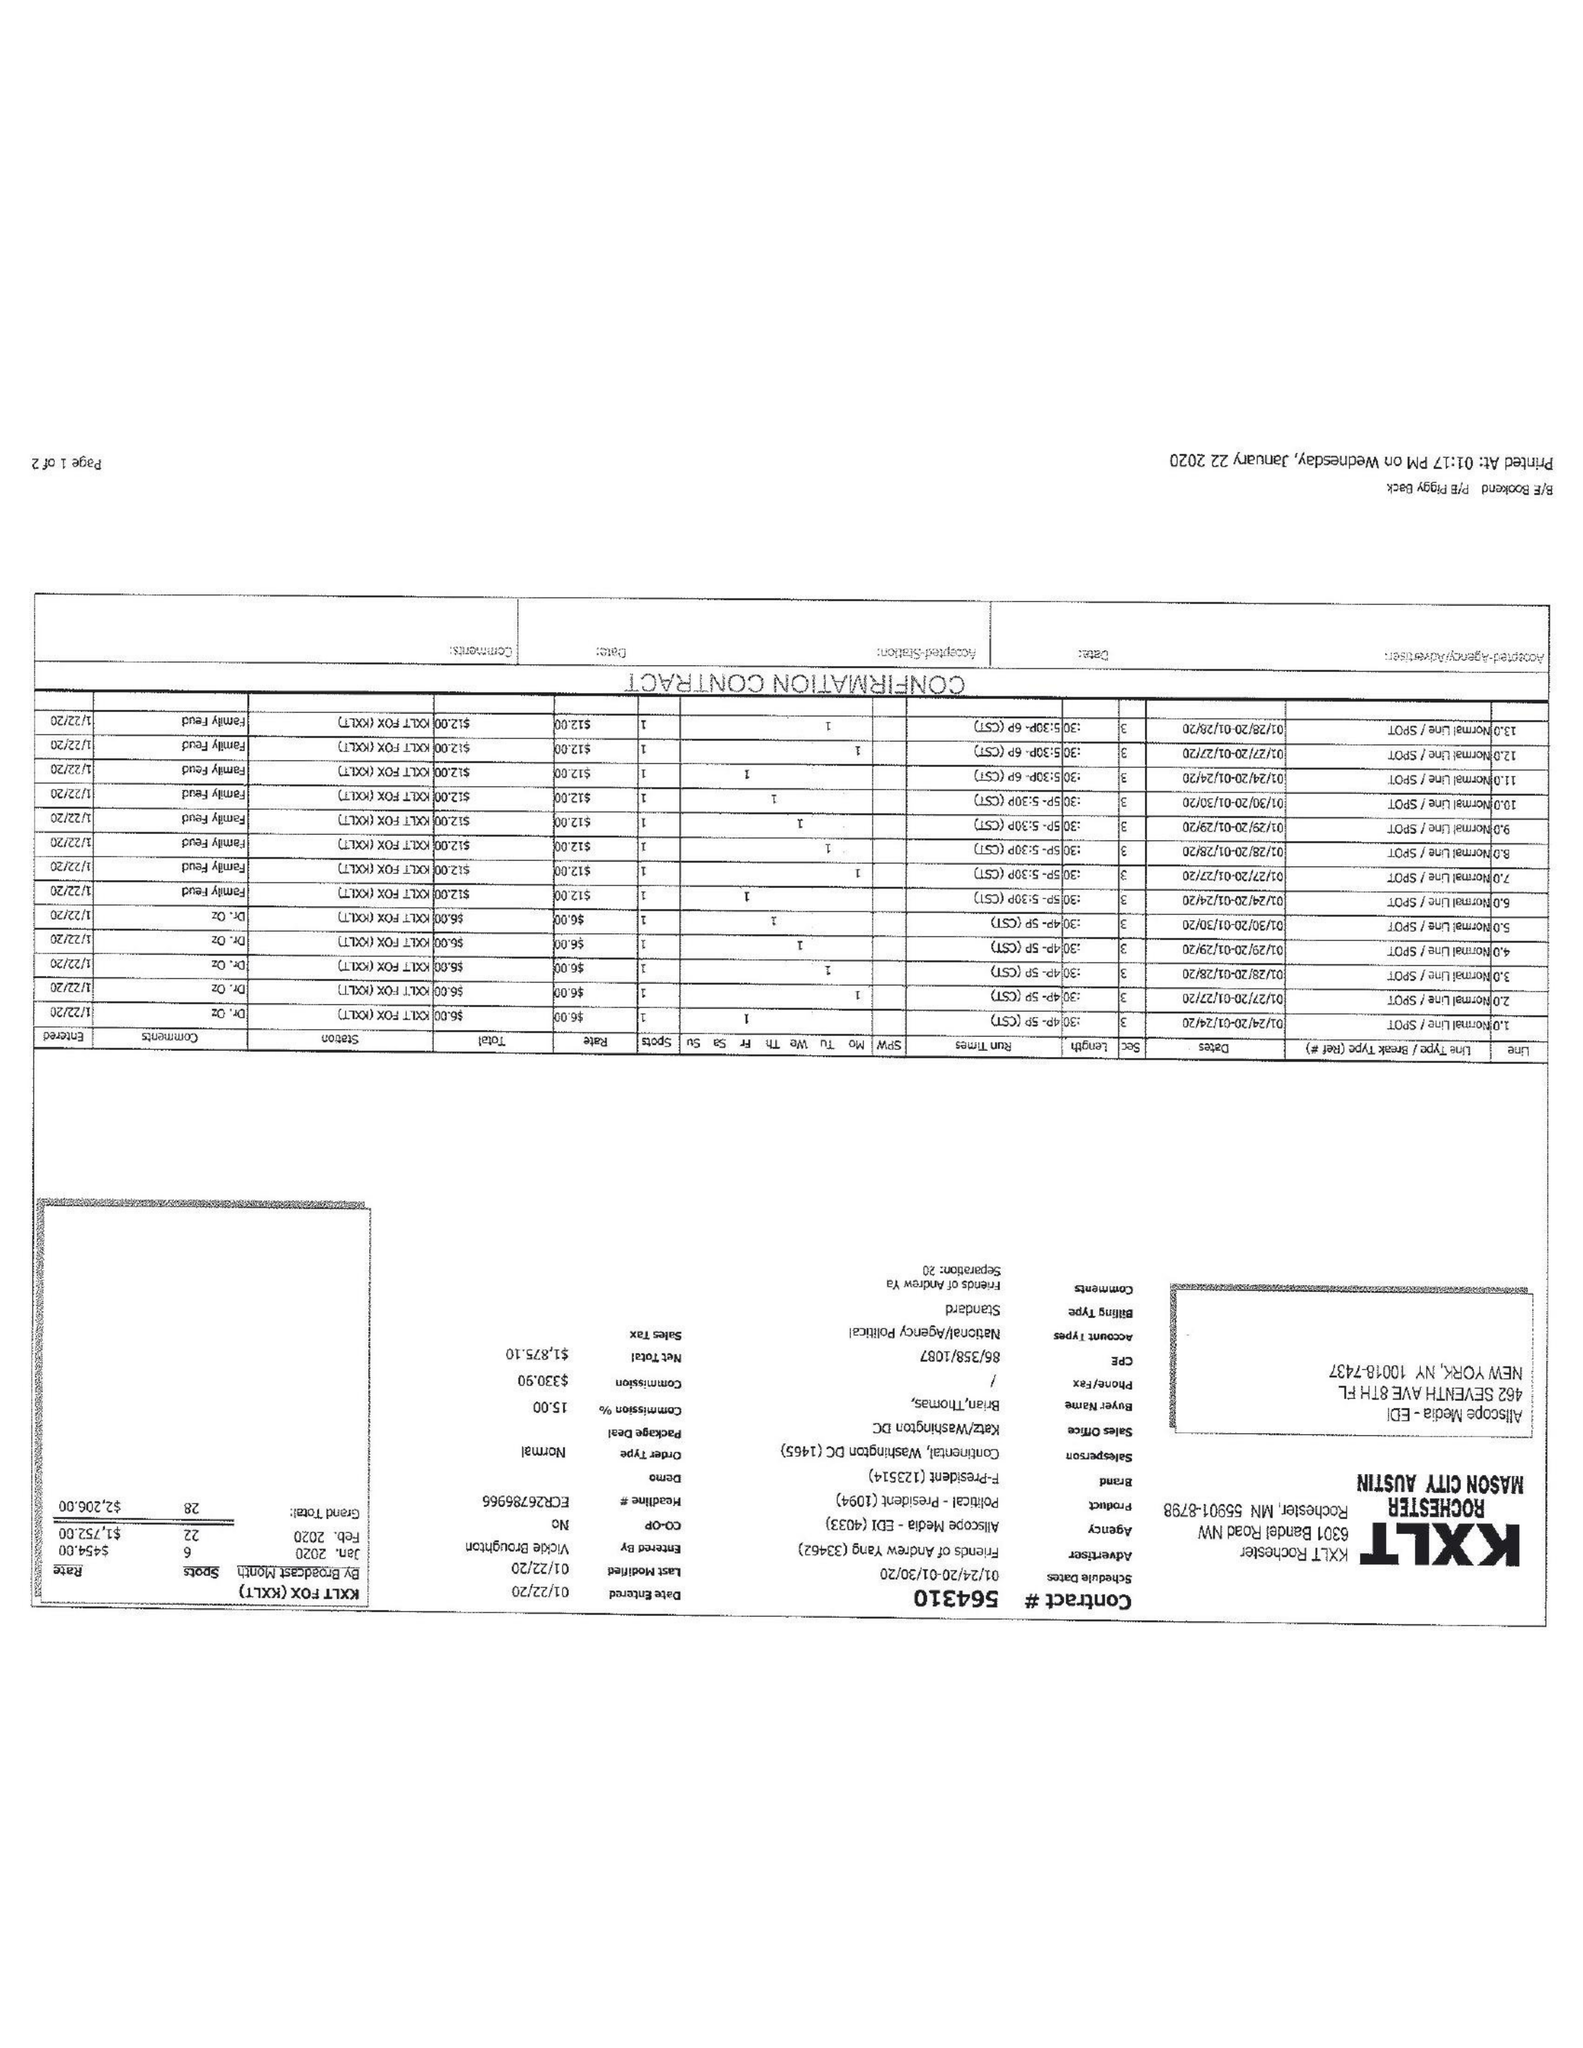What is the value for the flight_from?
Answer the question using a single word or phrase. 01/24/20 